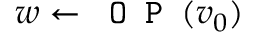Convert formula to latex. <formula><loc_0><loc_0><loc_500><loc_500>w \leftarrow O P ( v _ { 0 } )</formula> 